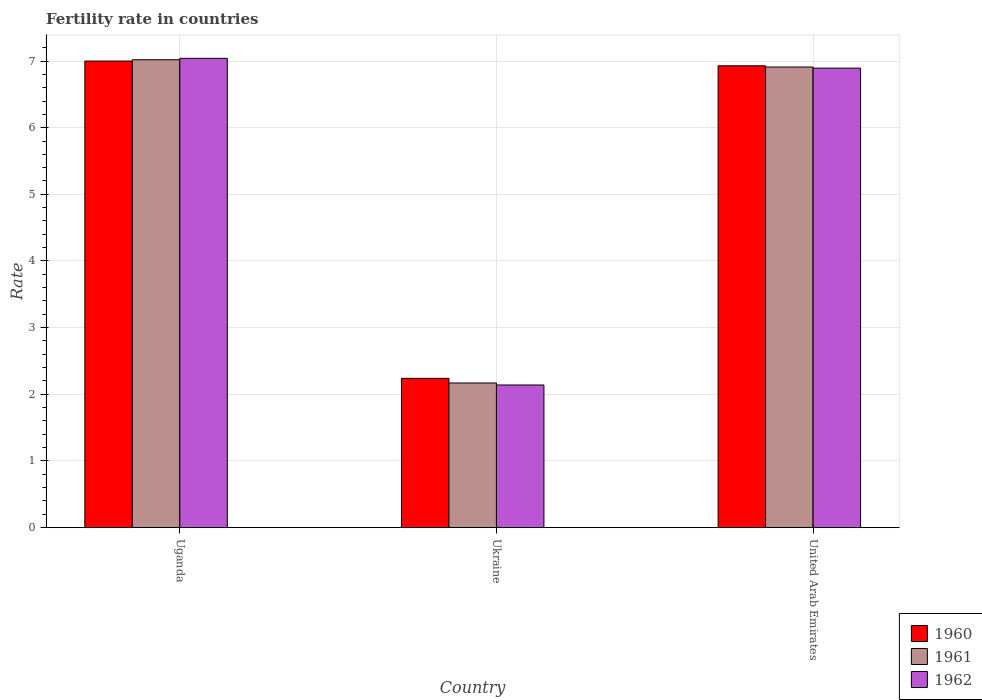How many different coloured bars are there?
Make the answer very short. 3. How many groups of bars are there?
Give a very brief answer. 3. How many bars are there on the 1st tick from the left?
Give a very brief answer. 3. How many bars are there on the 3rd tick from the right?
Offer a very short reply. 3. What is the label of the 3rd group of bars from the left?
Your answer should be compact. United Arab Emirates. What is the fertility rate in 1960 in Uganda?
Your response must be concise. 7. Across all countries, what is the maximum fertility rate in 1962?
Keep it short and to the point. 7.04. Across all countries, what is the minimum fertility rate in 1960?
Your answer should be compact. 2.24. In which country was the fertility rate in 1960 maximum?
Your answer should be very brief. Uganda. In which country was the fertility rate in 1962 minimum?
Ensure brevity in your answer.  Ukraine. What is the total fertility rate in 1960 in the graph?
Your answer should be very brief. 16.17. What is the difference between the fertility rate in 1960 in Uganda and that in Ukraine?
Give a very brief answer. 4.76. What is the difference between the fertility rate in 1961 in United Arab Emirates and the fertility rate in 1960 in Uganda?
Ensure brevity in your answer.  -0.09. What is the average fertility rate in 1960 per country?
Your answer should be compact. 5.39. What is the difference between the fertility rate of/in 1961 and fertility rate of/in 1960 in Ukraine?
Provide a succinct answer. -0.07. What is the ratio of the fertility rate in 1960 in Uganda to that in United Arab Emirates?
Give a very brief answer. 1.01. Is the fertility rate in 1961 in Ukraine less than that in United Arab Emirates?
Offer a very short reply. Yes. Is the difference between the fertility rate in 1961 in Uganda and United Arab Emirates greater than the difference between the fertility rate in 1960 in Uganda and United Arab Emirates?
Ensure brevity in your answer.  Yes. What is the difference between the highest and the second highest fertility rate in 1961?
Your response must be concise. -4.74. What is the difference between the highest and the lowest fertility rate in 1962?
Offer a terse response. 4.9. Is the sum of the fertility rate in 1962 in Uganda and Ukraine greater than the maximum fertility rate in 1961 across all countries?
Your response must be concise. Yes. What does the 2nd bar from the right in Ukraine represents?
Ensure brevity in your answer.  1961. Are all the bars in the graph horizontal?
Offer a terse response. No. What is the difference between two consecutive major ticks on the Y-axis?
Offer a very short reply. 1. Are the values on the major ticks of Y-axis written in scientific E-notation?
Your answer should be compact. No. Does the graph contain any zero values?
Offer a very short reply. No. Where does the legend appear in the graph?
Keep it short and to the point. Bottom right. How many legend labels are there?
Your answer should be very brief. 3. What is the title of the graph?
Keep it short and to the point. Fertility rate in countries. What is the label or title of the Y-axis?
Offer a terse response. Rate. What is the Rate of 1960 in Uganda?
Provide a succinct answer. 7. What is the Rate of 1961 in Uganda?
Offer a terse response. 7.02. What is the Rate in 1962 in Uganda?
Your answer should be very brief. 7.04. What is the Rate of 1960 in Ukraine?
Offer a terse response. 2.24. What is the Rate of 1961 in Ukraine?
Offer a very short reply. 2.17. What is the Rate of 1962 in Ukraine?
Your answer should be compact. 2.14. What is the Rate of 1960 in United Arab Emirates?
Offer a very short reply. 6.93. What is the Rate of 1961 in United Arab Emirates?
Make the answer very short. 6.91. What is the Rate in 1962 in United Arab Emirates?
Ensure brevity in your answer.  6.89. Across all countries, what is the maximum Rate in 1960?
Make the answer very short. 7. Across all countries, what is the maximum Rate in 1961?
Give a very brief answer. 7.02. Across all countries, what is the maximum Rate of 1962?
Offer a very short reply. 7.04. Across all countries, what is the minimum Rate in 1960?
Provide a succinct answer. 2.24. Across all countries, what is the minimum Rate of 1961?
Keep it short and to the point. 2.17. Across all countries, what is the minimum Rate of 1962?
Your answer should be very brief. 2.14. What is the total Rate of 1960 in the graph?
Offer a terse response. 16.17. What is the total Rate in 1961 in the graph?
Offer a terse response. 16.1. What is the total Rate in 1962 in the graph?
Your answer should be very brief. 16.07. What is the difference between the Rate of 1960 in Uganda and that in Ukraine?
Your answer should be compact. 4.76. What is the difference between the Rate of 1961 in Uganda and that in Ukraine?
Provide a succinct answer. 4.85. What is the difference between the Rate of 1962 in Uganda and that in Ukraine?
Offer a very short reply. 4.9. What is the difference between the Rate of 1960 in Uganda and that in United Arab Emirates?
Give a very brief answer. 0.07. What is the difference between the Rate of 1961 in Uganda and that in United Arab Emirates?
Make the answer very short. 0.11. What is the difference between the Rate of 1962 in Uganda and that in United Arab Emirates?
Offer a terse response. 0.15. What is the difference between the Rate of 1960 in Ukraine and that in United Arab Emirates?
Ensure brevity in your answer.  -4.69. What is the difference between the Rate in 1961 in Ukraine and that in United Arab Emirates?
Provide a succinct answer. -4.74. What is the difference between the Rate in 1962 in Ukraine and that in United Arab Emirates?
Offer a terse response. -4.75. What is the difference between the Rate in 1960 in Uganda and the Rate in 1961 in Ukraine?
Your answer should be very brief. 4.83. What is the difference between the Rate of 1960 in Uganda and the Rate of 1962 in Ukraine?
Your answer should be very brief. 4.86. What is the difference between the Rate of 1961 in Uganda and the Rate of 1962 in Ukraine?
Provide a succinct answer. 4.88. What is the difference between the Rate of 1960 in Uganda and the Rate of 1961 in United Arab Emirates?
Ensure brevity in your answer.  0.09. What is the difference between the Rate of 1960 in Uganda and the Rate of 1962 in United Arab Emirates?
Provide a succinct answer. 0.11. What is the difference between the Rate in 1961 in Uganda and the Rate in 1962 in United Arab Emirates?
Your response must be concise. 0.13. What is the difference between the Rate of 1960 in Ukraine and the Rate of 1961 in United Arab Emirates?
Give a very brief answer. -4.67. What is the difference between the Rate of 1960 in Ukraine and the Rate of 1962 in United Arab Emirates?
Your response must be concise. -4.65. What is the difference between the Rate in 1961 in Ukraine and the Rate in 1962 in United Arab Emirates?
Ensure brevity in your answer.  -4.72. What is the average Rate in 1960 per country?
Offer a terse response. 5.39. What is the average Rate of 1961 per country?
Offer a terse response. 5.37. What is the average Rate in 1962 per country?
Offer a terse response. 5.36. What is the difference between the Rate in 1960 and Rate in 1961 in Uganda?
Provide a short and direct response. -0.02. What is the difference between the Rate in 1960 and Rate in 1962 in Uganda?
Offer a terse response. -0.04. What is the difference between the Rate in 1961 and Rate in 1962 in Uganda?
Your answer should be very brief. -0.02. What is the difference between the Rate in 1960 and Rate in 1961 in Ukraine?
Make the answer very short. 0.07. What is the difference between the Rate in 1960 and Rate in 1962 in Ukraine?
Your answer should be compact. 0.1. What is the difference between the Rate in 1961 and Rate in 1962 in Ukraine?
Make the answer very short. 0.03. What is the difference between the Rate in 1960 and Rate in 1961 in United Arab Emirates?
Give a very brief answer. 0.02. What is the difference between the Rate in 1960 and Rate in 1962 in United Arab Emirates?
Your answer should be compact. 0.04. What is the difference between the Rate in 1961 and Rate in 1962 in United Arab Emirates?
Ensure brevity in your answer.  0.02. What is the ratio of the Rate of 1960 in Uganda to that in Ukraine?
Your answer should be compact. 3.12. What is the ratio of the Rate of 1961 in Uganda to that in Ukraine?
Your answer should be compact. 3.23. What is the ratio of the Rate of 1962 in Uganda to that in Ukraine?
Your answer should be very brief. 3.29. What is the ratio of the Rate of 1960 in Uganda to that in United Arab Emirates?
Ensure brevity in your answer.  1.01. What is the ratio of the Rate of 1961 in Uganda to that in United Arab Emirates?
Ensure brevity in your answer.  1.02. What is the ratio of the Rate in 1962 in Uganda to that in United Arab Emirates?
Provide a short and direct response. 1.02. What is the ratio of the Rate of 1960 in Ukraine to that in United Arab Emirates?
Ensure brevity in your answer.  0.32. What is the ratio of the Rate in 1961 in Ukraine to that in United Arab Emirates?
Keep it short and to the point. 0.31. What is the ratio of the Rate in 1962 in Ukraine to that in United Arab Emirates?
Ensure brevity in your answer.  0.31. What is the difference between the highest and the second highest Rate of 1960?
Make the answer very short. 0.07. What is the difference between the highest and the second highest Rate in 1961?
Ensure brevity in your answer.  0.11. What is the difference between the highest and the second highest Rate of 1962?
Offer a very short reply. 0.15. What is the difference between the highest and the lowest Rate of 1960?
Ensure brevity in your answer.  4.76. What is the difference between the highest and the lowest Rate in 1961?
Provide a succinct answer. 4.85. 